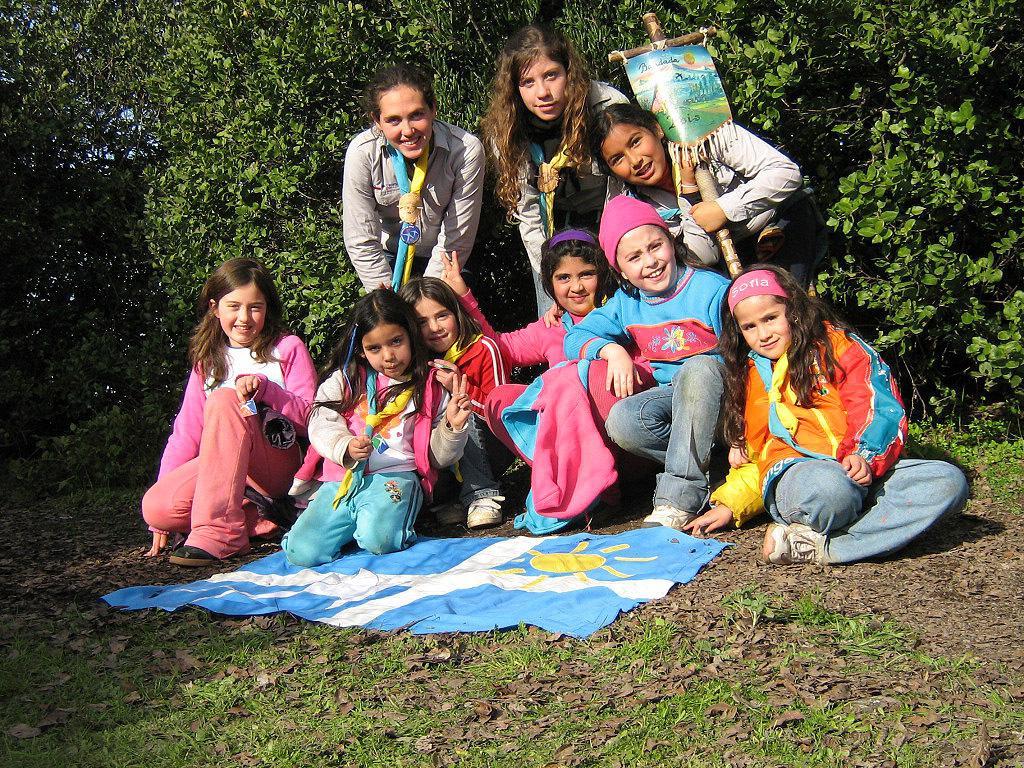Describe this image in one or two sentences. In this image we can see a few people among them some are holding the objects, we can see some grass, leaves and a cloth on the ground. In the background there are some trees. 